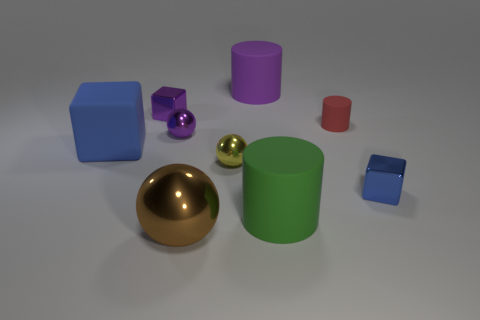There is a purple cylinder that is the same size as the rubber cube; what is it made of?
Your answer should be very brief. Rubber. There is a cube that is left of the purple rubber cylinder and in front of the tiny purple metal cube; what size is it?
Your answer should be compact. Large. The big thing that is both in front of the yellow ball and behind the brown thing is what color?
Your answer should be very brief. Green. Are there fewer yellow balls that are on the right side of the tiny purple sphere than matte objects that are on the right side of the brown shiny sphere?
Offer a terse response. Yes. What number of small rubber objects are the same shape as the big green rubber thing?
Offer a very short reply. 1. What size is the purple cylinder that is made of the same material as the tiny red cylinder?
Provide a succinct answer. Large. What is the color of the big matte cylinder that is to the right of the rubber thing behind the small red rubber cylinder?
Make the answer very short. Green. There is a tiny yellow shiny object; is its shape the same as the thing on the right side of the tiny matte cylinder?
Your answer should be compact. No. What number of objects are the same size as the purple metal block?
Your answer should be compact. 4. There is another large thing that is the same shape as the large green object; what is it made of?
Your answer should be very brief. Rubber. 